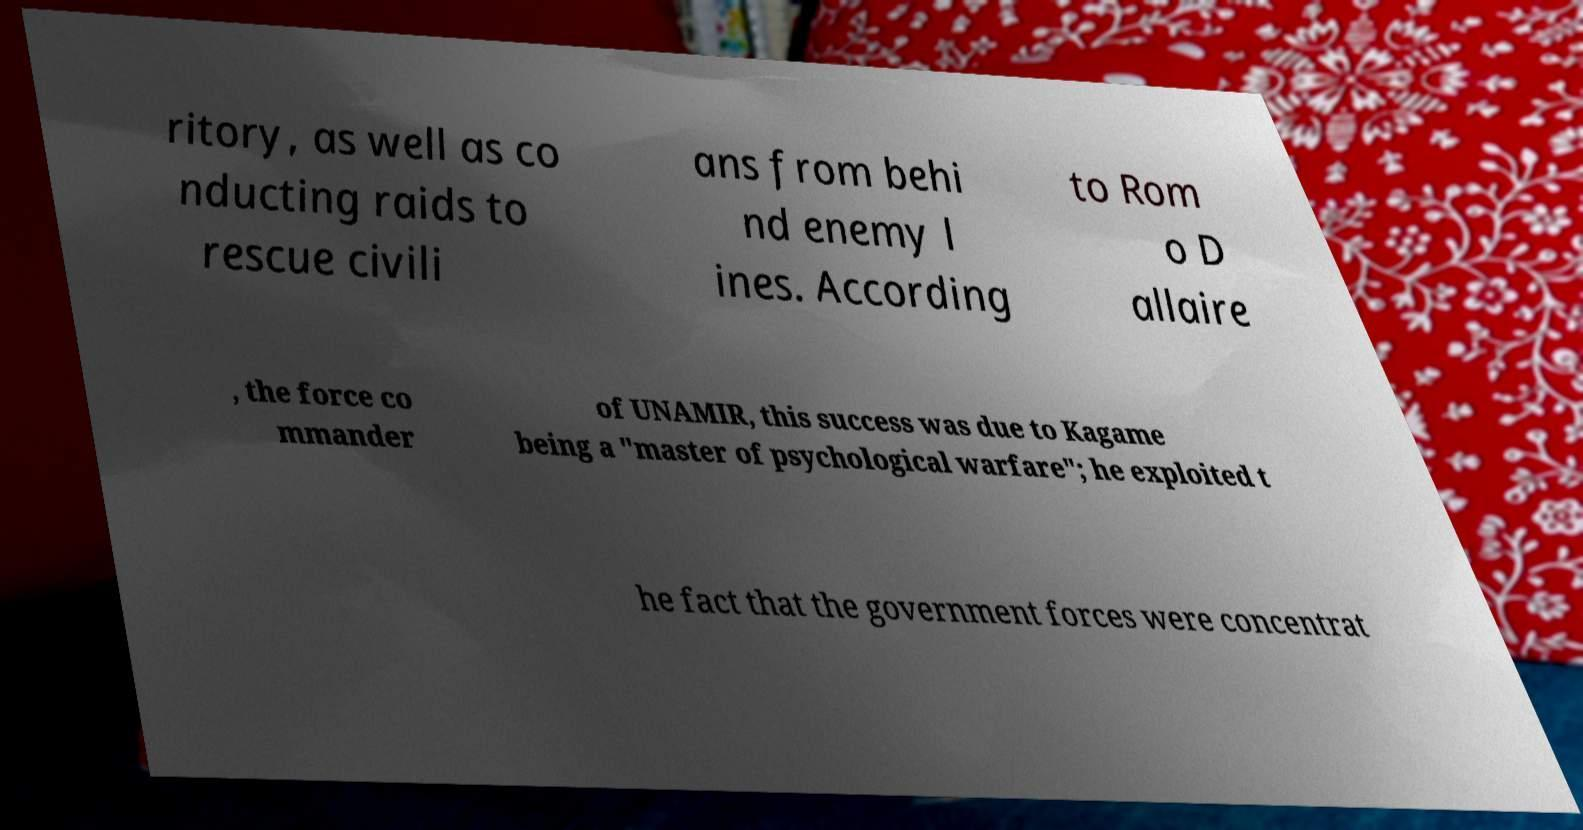There's text embedded in this image that I need extracted. Can you transcribe it verbatim? ritory, as well as co nducting raids to rescue civili ans from behi nd enemy l ines. According to Rom o D allaire , the force co mmander of UNAMIR, this success was due to Kagame being a "master of psychological warfare"; he exploited t he fact that the government forces were concentrat 